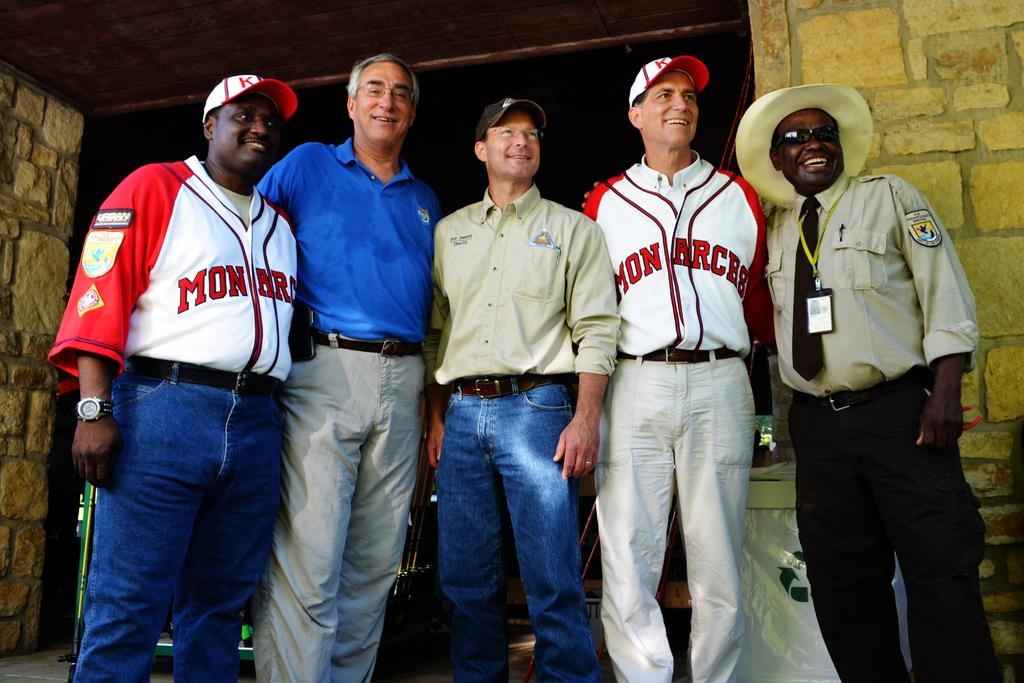<image>
Present a compact description of the photo's key features. Five people pose for a photograph together, two of whom are wearing Monarchs jerseys. 